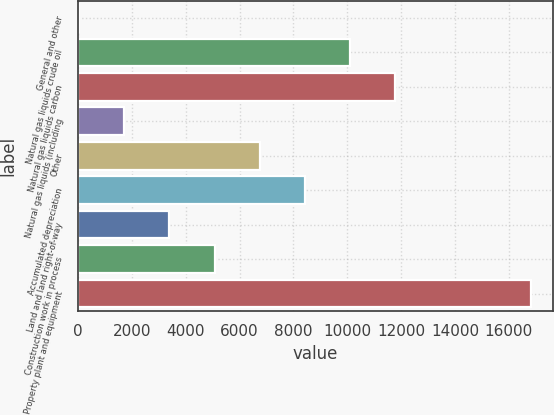<chart> <loc_0><loc_0><loc_500><loc_500><bar_chart><fcel>General and other<fcel>Natural gas liquids crude oil<fcel>Natural gas liquids carbon<fcel>Natural gas liquids (including<fcel>Other<fcel>Accumulated depreciation<fcel>Land and land right-of-way<fcel>Construction work in process<fcel>Property plant and equipment<nl><fcel>45.7<fcel>10100.4<fcel>11776.2<fcel>1721.48<fcel>6748.82<fcel>8424.6<fcel>3397.26<fcel>5073.04<fcel>16803.5<nl></chart> 